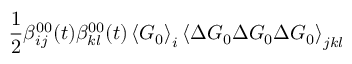Convert formula to latex. <formula><loc_0><loc_0><loc_500><loc_500>\frac { 1 } { 2 } \beta _ { i j } ^ { 0 0 } ( t ) \beta _ { k l } ^ { 0 0 } ( t ) \left \langle G _ { 0 } \right \rangle _ { i } \left \langle \Delta G _ { 0 } \Delta G _ { 0 } \Delta G _ { 0 } \right \rangle _ { j k l }</formula> 